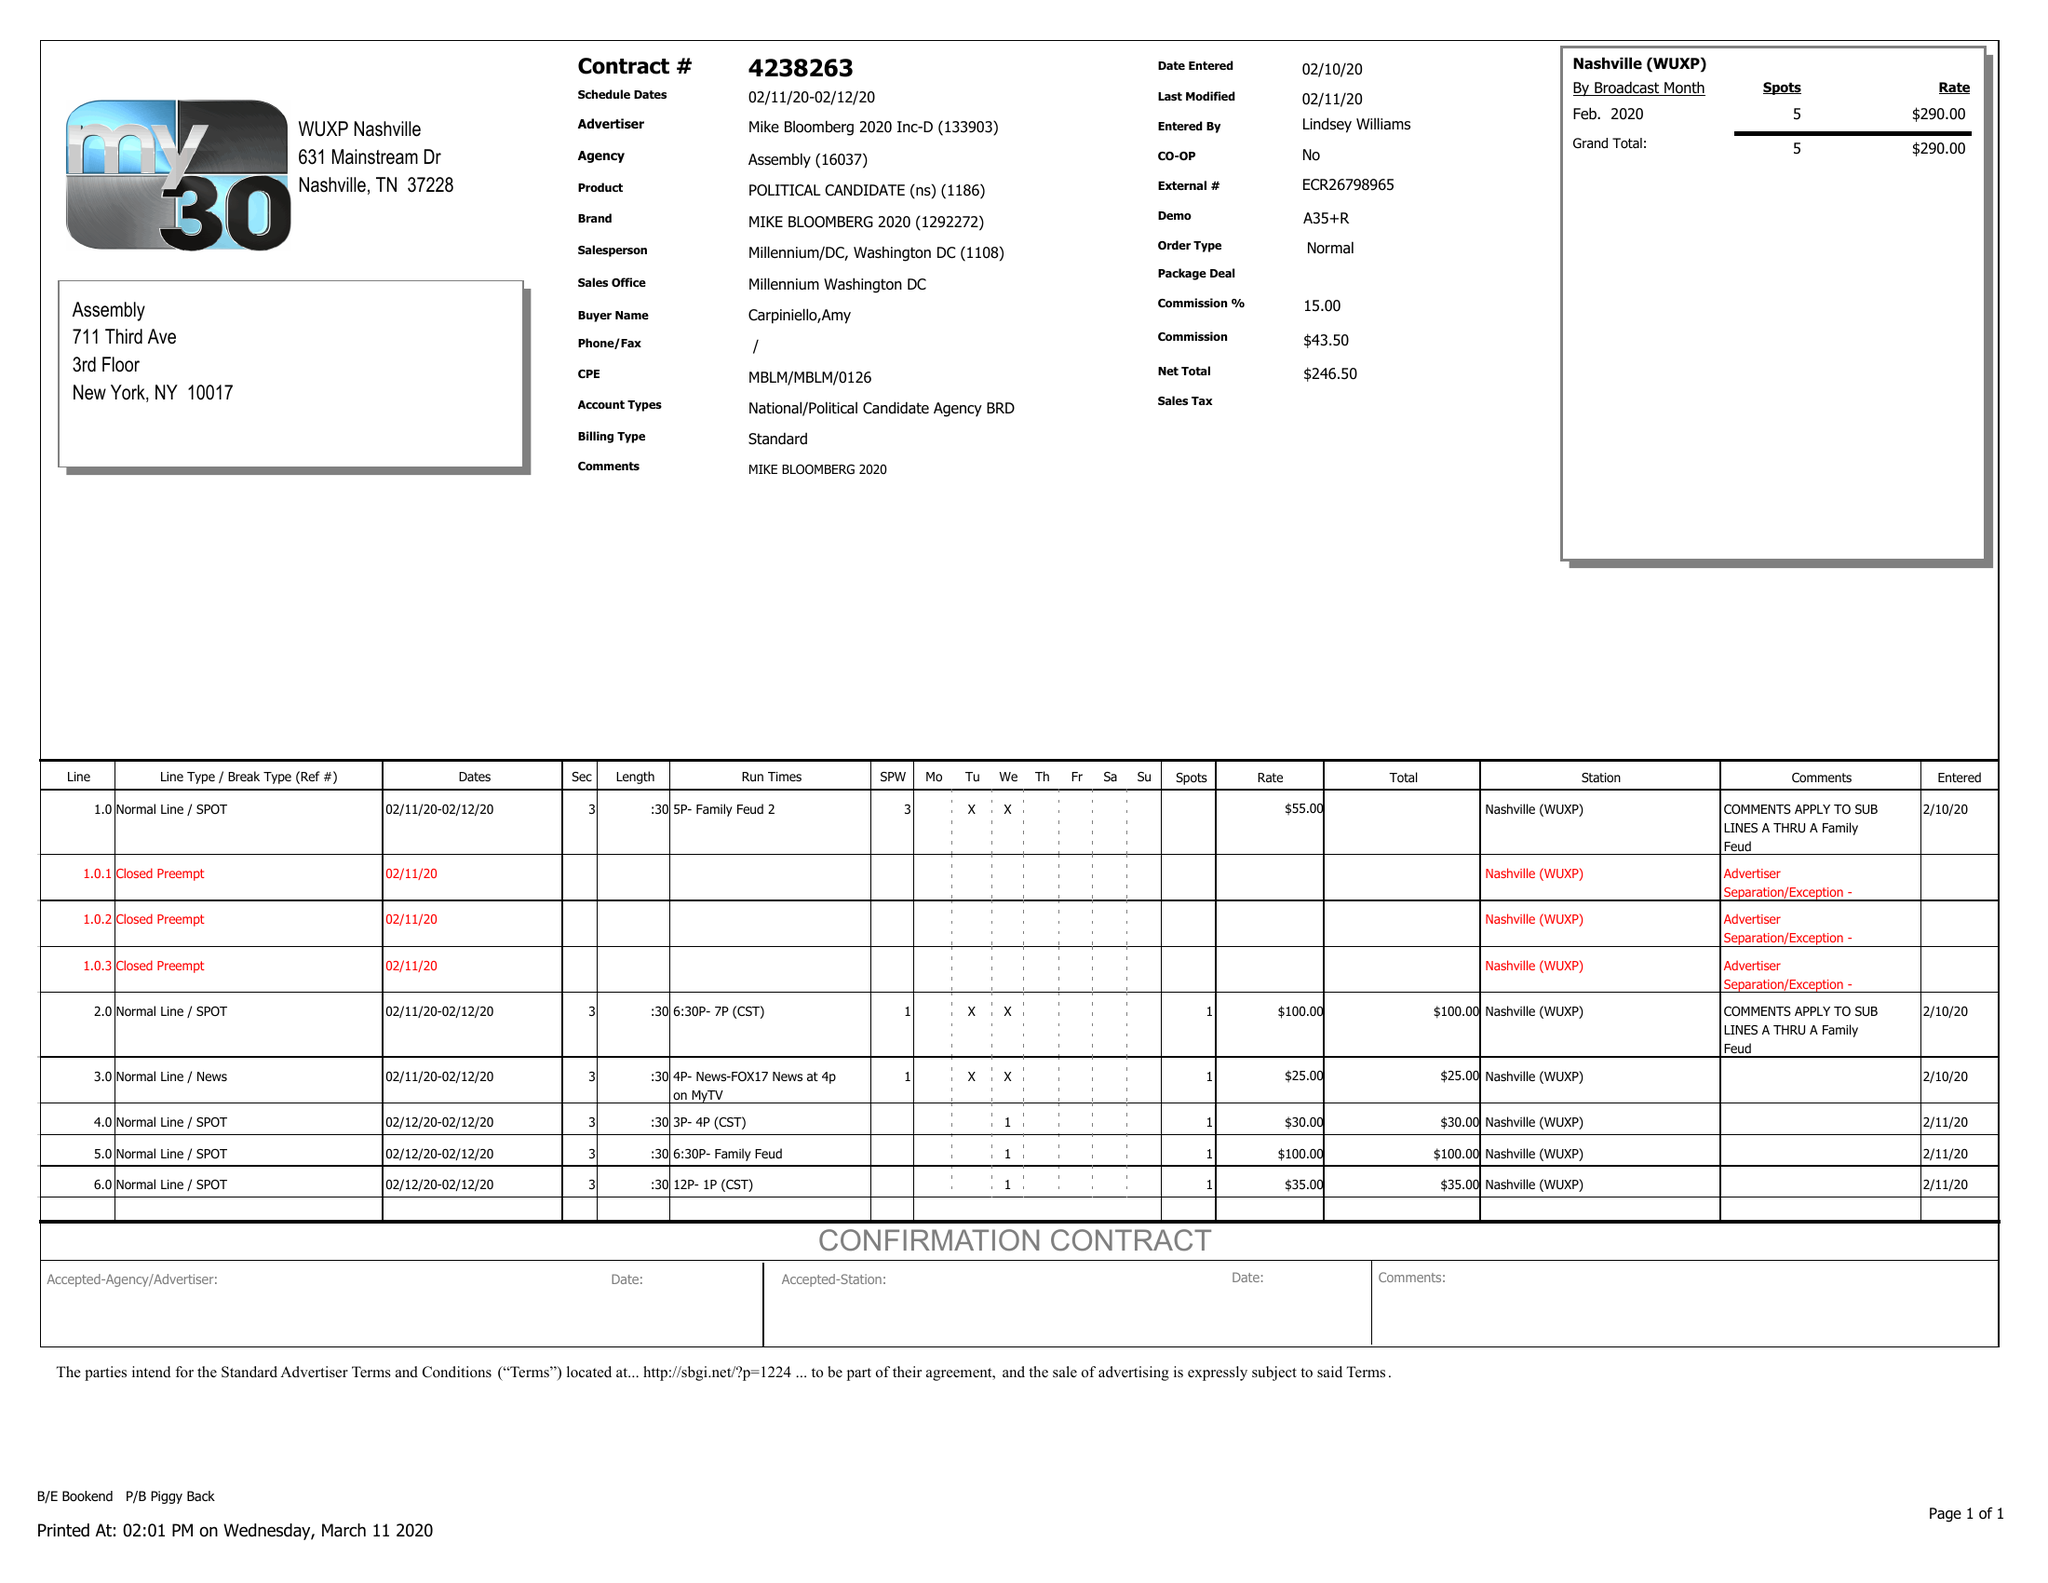What is the value for the gross_amount?
Answer the question using a single word or phrase. 290.00 